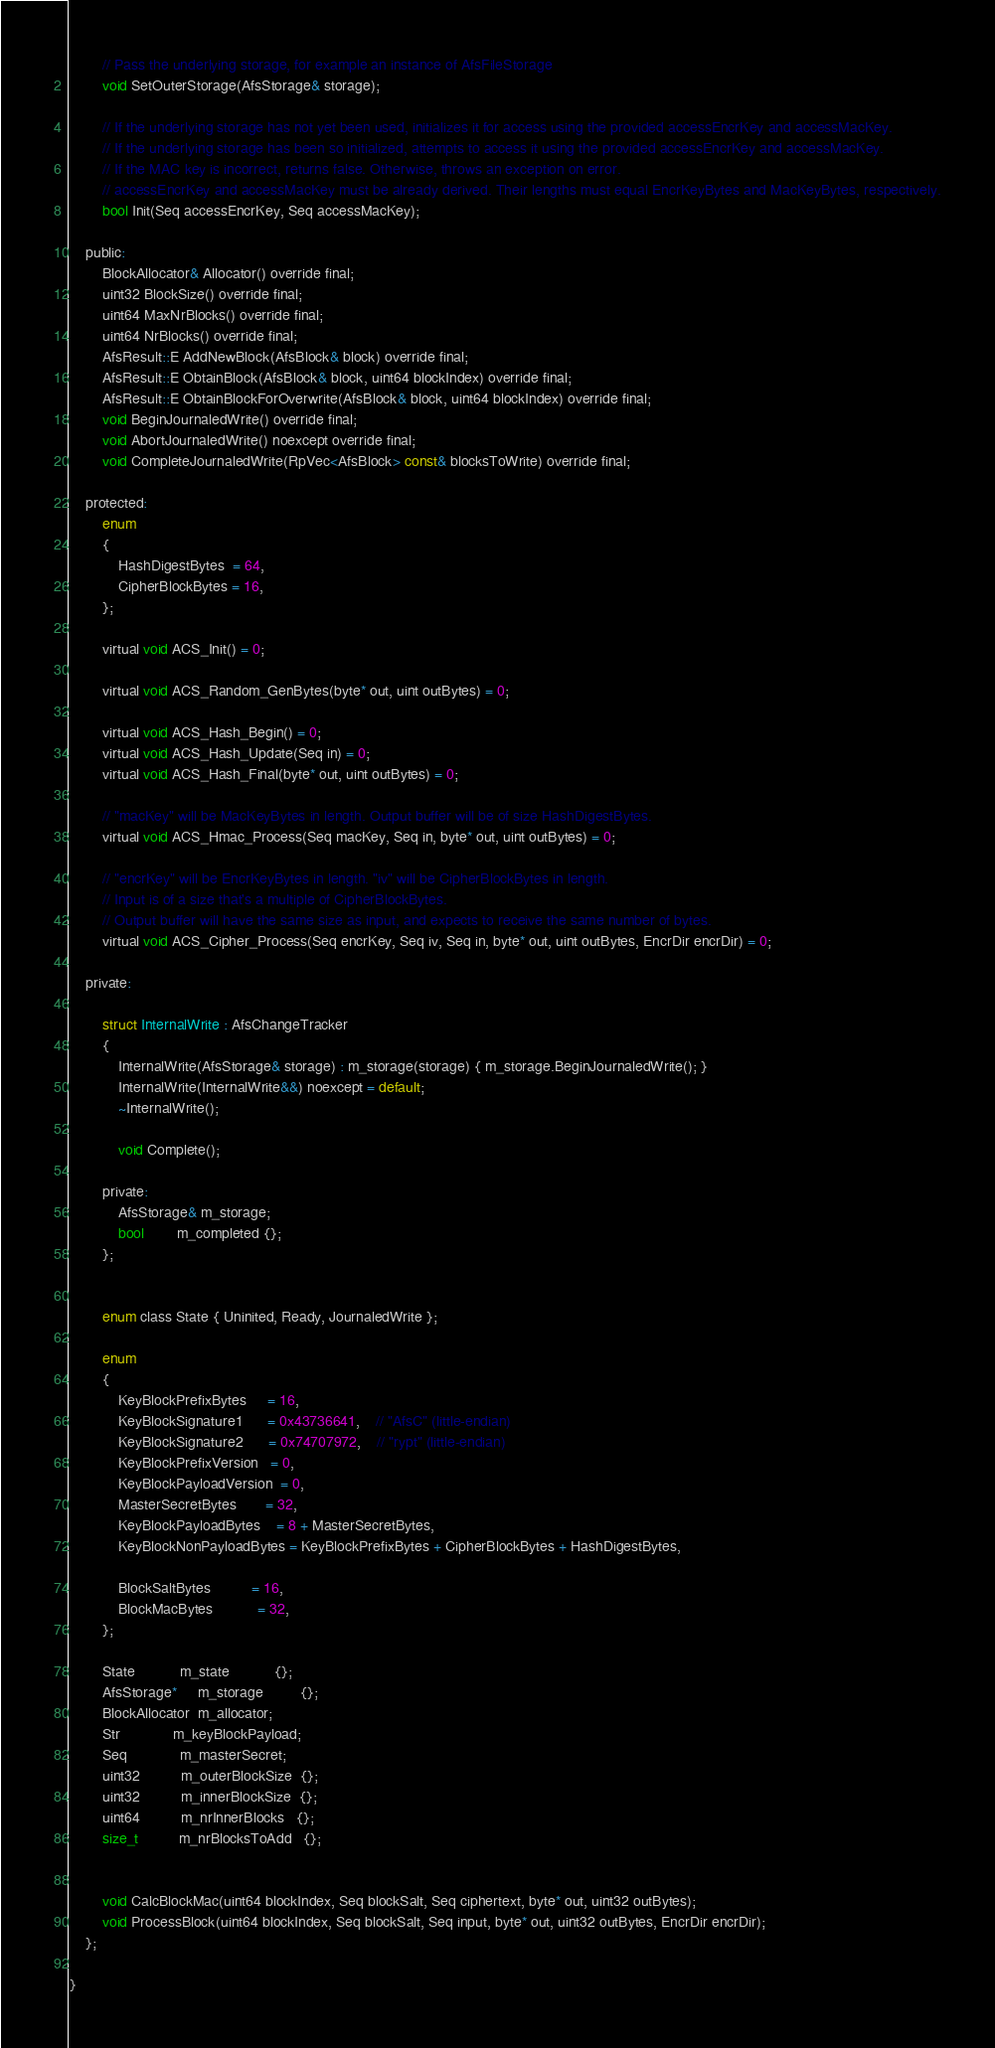Convert code to text. <code><loc_0><loc_0><loc_500><loc_500><_C_>		// Pass the underlying storage, for example an instance of AfsFileStorage
		void SetOuterStorage(AfsStorage& storage);

		// If the underlying storage has not yet been used, initializes it for access using the provided accessEncrKey and accessMacKey.
		// If the underlying storage has been so initialized, attempts to access it using the provided accessEncrKey and accessMacKey.
		// If the MAC key is incorrect, returns false. Otherwise, throws an exception on error.
		// accessEncrKey and accessMacKey must be already derived. Their lengths must equal EncrKeyBytes and MacKeyBytes, respectively.
		bool Init(Seq accessEncrKey, Seq accessMacKey);

	public:
		BlockAllocator& Allocator() override final;
		uint32 BlockSize() override final;
		uint64 MaxNrBlocks() override final;
		uint64 NrBlocks() override final;
		AfsResult::E AddNewBlock(AfsBlock& block) override final;
		AfsResult::E ObtainBlock(AfsBlock& block, uint64 blockIndex) override final;
		AfsResult::E ObtainBlockForOverwrite(AfsBlock& block, uint64 blockIndex) override final;
		void BeginJournaledWrite() override final;
		void AbortJournaledWrite() noexcept override final;
		void CompleteJournaledWrite(RpVec<AfsBlock> const& blocksToWrite) override final;

	protected:
		enum
		{
			HashDigestBytes  = 64,
			CipherBlockBytes = 16,
		};

		virtual void ACS_Init() = 0;

		virtual void ACS_Random_GenBytes(byte* out, uint outBytes) = 0;

		virtual void ACS_Hash_Begin() = 0;
		virtual void ACS_Hash_Update(Seq in) = 0;
		virtual void ACS_Hash_Final(byte* out, uint outBytes) = 0;

		// "macKey" will be MacKeyBytes in length. Output buffer will be of size HashDigestBytes.
		virtual void ACS_Hmac_Process(Seq macKey, Seq in, byte* out, uint outBytes) = 0;

		// "encrKey" will be EncrKeyBytes in length. "iv" will be CipherBlockBytes in length.
		// Input is of a size that's a multiple of CipherBlockBytes.
		// Output buffer will have the same size as input, and expects to receive the same number of bytes.
		virtual void ACS_Cipher_Process(Seq encrKey, Seq iv, Seq in, byte* out, uint outBytes, EncrDir encrDir) = 0;

	private:

		struct InternalWrite : AfsChangeTracker
		{
			InternalWrite(AfsStorage& storage) : m_storage(storage) { m_storage.BeginJournaledWrite(); }
			InternalWrite(InternalWrite&&) noexcept = default;
			~InternalWrite();

			void Complete();

		private:
			AfsStorage& m_storage;
			bool        m_completed {};
		};


		enum class State { Uninited, Ready, JournaledWrite };

		enum
		{
			KeyBlockPrefixBytes     = 16,
			KeyBlockSignature1      = 0x43736641,	// "AfsC" (little-endian)
			KeyBlockSignature2      = 0x74707972,	// "rypt" (little-endian)
			KeyBlockPrefixVersion   = 0,
			KeyBlockPayloadVersion  = 0,
			MasterSecretBytes       = 32,
			KeyBlockPayloadBytes    = 8 + MasterSecretBytes,
			KeyBlockNonPayloadBytes = KeyBlockPrefixBytes + CipherBlockBytes + HashDigestBytes,

			BlockSaltBytes          = 16,
			BlockMacBytes           = 32,
		};

		State           m_state           {};
		AfsStorage*     m_storage         {};
		BlockAllocator  m_allocator;
		Str             m_keyBlockPayload;
		Seq             m_masterSecret;
		uint32          m_outerBlockSize  {};
		uint32          m_innerBlockSize  {};
		uint64          m_nrInnerBlocks   {};
		size_t          m_nrBlocksToAdd   {};


		void CalcBlockMac(uint64 blockIndex, Seq blockSalt, Seq ciphertext, byte* out, uint32 outBytes);
		void ProcessBlock(uint64 blockIndex, Seq blockSalt, Seq input, byte* out, uint32 outBytes, EncrDir encrDir);
	};

}
</code> 